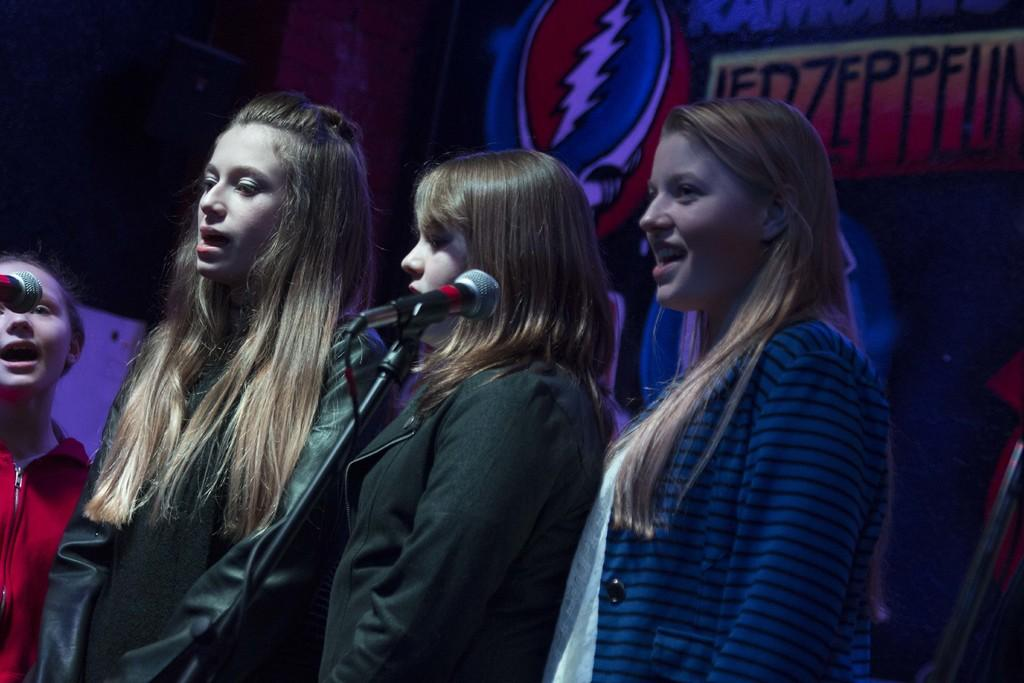How many people are in the image? There are four girls in the image. What are the girls doing in the image? The girls are standing and singing a song. What can be seen behind the girls? There is a banner behind the girls. Can you see any thumbs in the image? There are no thumbs visible in the image. Where is the park located in the image? There is no park present in the image. 